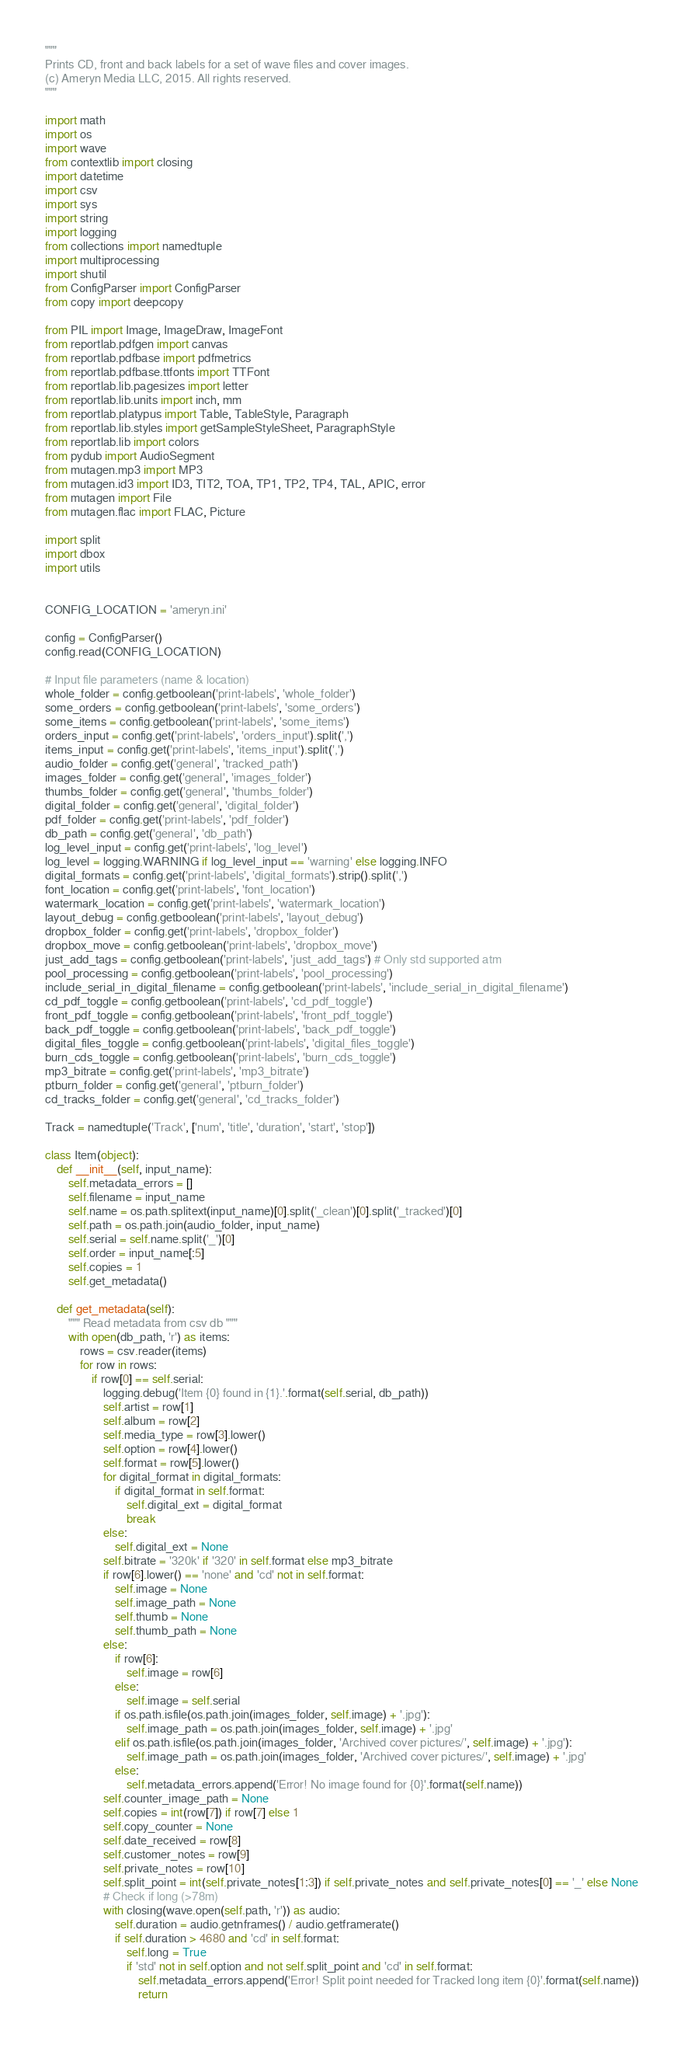<code> <loc_0><loc_0><loc_500><loc_500><_Python_>"""
Prints CD, front and back labels for a set of wave files and cover images.
(c) Ameryn Media LLC, 2015. All rights reserved.
"""

import math
import os
import wave
from contextlib import closing
import datetime
import csv
import sys
import string
import logging
from collections import namedtuple
import multiprocessing
import shutil
from ConfigParser import ConfigParser
from copy import deepcopy

from PIL import Image, ImageDraw, ImageFont
from reportlab.pdfgen import canvas
from reportlab.pdfbase import pdfmetrics  
from reportlab.pdfbase.ttfonts import TTFont
from reportlab.lib.pagesizes import letter
from reportlab.lib.units import inch, mm
from reportlab.platypus import Table, TableStyle, Paragraph
from reportlab.lib.styles import getSampleStyleSheet, ParagraphStyle
from reportlab.lib import colors
from pydub import AudioSegment
from mutagen.mp3 import MP3
from mutagen.id3 import ID3, TIT2, TOA, TP1, TP2, TP4, TAL, APIC, error
from mutagen import File
from mutagen.flac import FLAC, Picture

import split
import dbox
import utils


CONFIG_LOCATION = 'ameryn.ini'

config = ConfigParser()
config.read(CONFIG_LOCATION)

# Input file parameters (name & location)
whole_folder = config.getboolean('print-labels', 'whole_folder')
some_orders = config.getboolean('print-labels', 'some_orders')
some_items = config.getboolean('print-labels', 'some_items')
orders_input = config.get('print-labels', 'orders_input').split(',')
items_input = config.get('print-labels', 'items_input').split(',')
audio_folder = config.get('general', 'tracked_path')
images_folder = config.get('general', 'images_folder')
thumbs_folder = config.get('general', 'thumbs_folder')
digital_folder = config.get('general', 'digital_folder')
pdf_folder = config.get('print-labels', 'pdf_folder')
db_path = config.get('general', 'db_path')
log_level_input = config.get('print-labels', 'log_level')
log_level = logging.WARNING if log_level_input == 'warning' else logging.INFO
digital_formats = config.get('print-labels', 'digital_formats').strip().split(',')
font_location = config.get('print-labels', 'font_location')
watermark_location = config.get('print-labels', 'watermark_location')
layout_debug = config.getboolean('print-labels', 'layout_debug')
dropbox_folder = config.get('print-labels', 'dropbox_folder')
dropbox_move = config.getboolean('print-labels', 'dropbox_move')
just_add_tags = config.getboolean('print-labels', 'just_add_tags') # Only std supported atm
pool_processing = config.getboolean('print-labels', 'pool_processing')
include_serial_in_digital_filename = config.getboolean('print-labels', 'include_serial_in_digital_filename')
cd_pdf_toggle = config.getboolean('print-labels', 'cd_pdf_toggle')
front_pdf_toggle = config.getboolean('print-labels', 'front_pdf_toggle')
back_pdf_toggle = config.getboolean('print-labels', 'back_pdf_toggle')
digital_files_toggle = config.getboolean('print-labels', 'digital_files_toggle')
burn_cds_toggle = config.getboolean('print-labels', 'burn_cds_toggle')
mp3_bitrate = config.get('print-labels', 'mp3_bitrate')
ptburn_folder = config.get('general', 'ptburn_folder')
cd_tracks_folder = config.get('general', 'cd_tracks_folder')

Track = namedtuple('Track', ['num', 'title', 'duration', 'start', 'stop'])

class Item(object):
    def __init__(self, input_name):
        self.metadata_errors = []
        self.filename = input_name
        self.name = os.path.splitext(input_name)[0].split('_clean')[0].split('_tracked')[0]
        self.path = os.path.join(audio_folder, input_name)
        self.serial = self.name.split('_')[0]
        self.order = input_name[:5]
        self.copies = 1
        self.get_metadata()

    def get_metadata(self):
        """ Read metadata from csv db """
        with open(db_path, 'r') as items:
            rows = csv.reader(items)
            for row in rows:
                if row[0] == self.serial:
                    logging.debug('Item {0} found in {1}.'.format(self.serial, db_path))
                    self.artist = row[1]
                    self.album = row[2]
                    self.media_type = row[3].lower()
                    self.option = row[4].lower()
                    self.format = row[5].lower()
                    for digital_format in digital_formats:
                        if digital_format in self.format:
                            self.digital_ext = digital_format
                            break
                    else:
                        self.digital_ext = None                    
                    self.bitrate = '320k' if '320' in self.format else mp3_bitrate
                    if row[6].lower() == 'none' and 'cd' not in self.format:
                        self.image = None
                        self.image_path = None
                        self.thumb = None
                        self.thumb_path = None
                    else:
                        if row[6]:
                            self.image = row[6]
                        else:
                            self.image = self.serial
                        if os.path.isfile(os.path.join(images_folder, self.image) + '.jpg'):
                            self.image_path = os.path.join(images_folder, self.image) + '.jpg'
                        elif os.path.isfile(os.path.join(images_folder, 'Archived cover pictures/', self.image) + '.jpg'):
                            self.image_path = os.path.join(images_folder, 'Archived cover pictures/', self.image) + '.jpg'
                        else:
                            self.metadata_errors.append('Error! No image found for {0}'.format(self.name))
                    self.counter_image_path = None
                    self.copies = int(row[7]) if row[7] else 1
                    self.copy_counter = None
                    self.date_received = row[8]
                    self.customer_notes = row[9]
                    self.private_notes = row[10]
                    self.split_point = int(self.private_notes[1:3]) if self.private_notes and self.private_notes[0] == '_' else None
                    # Check if long (>78m)
                    with closing(wave.open(self.path, 'r')) as audio:
                        self.duration = audio.getnframes() / audio.getframerate()
                        if self.duration > 4680 and 'cd' in self.format:
                            self.long = True
                            if 'std' not in self.option and not self.split_point and 'cd' in self.format:
                                self.metadata_errors.append('Error! Split point needed for Tracked long item {0}'.format(self.name))
                                return</code> 